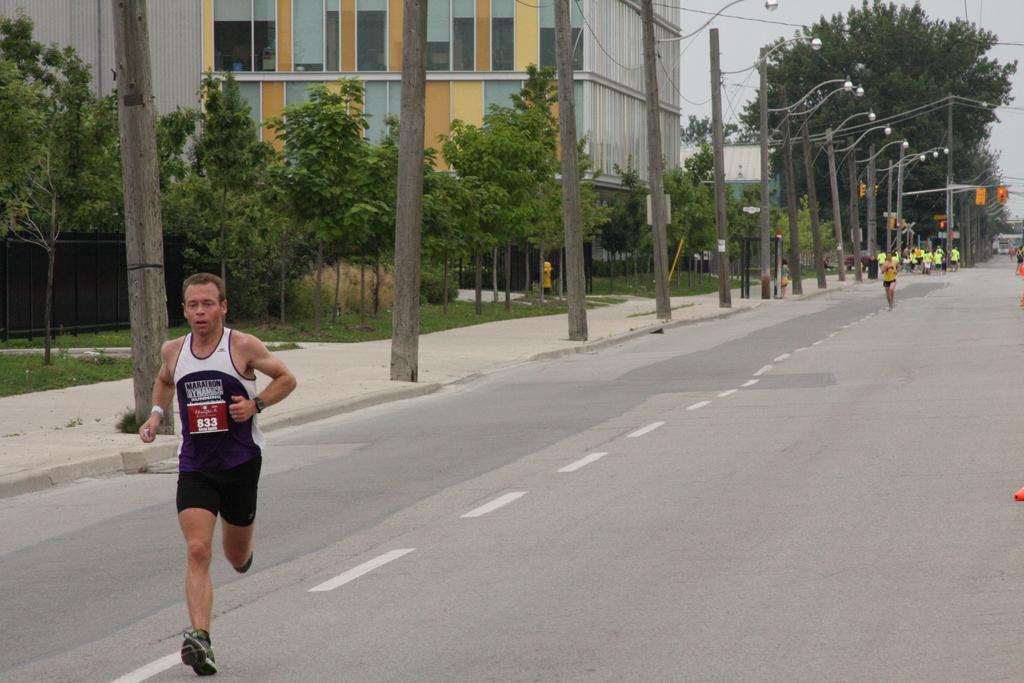Can you describe this image briefly? This picture shows a man running on the road and we see few people running on the back and we see trees and buildings and feud and pole lights on the sidewalk and a cloudy Sky 